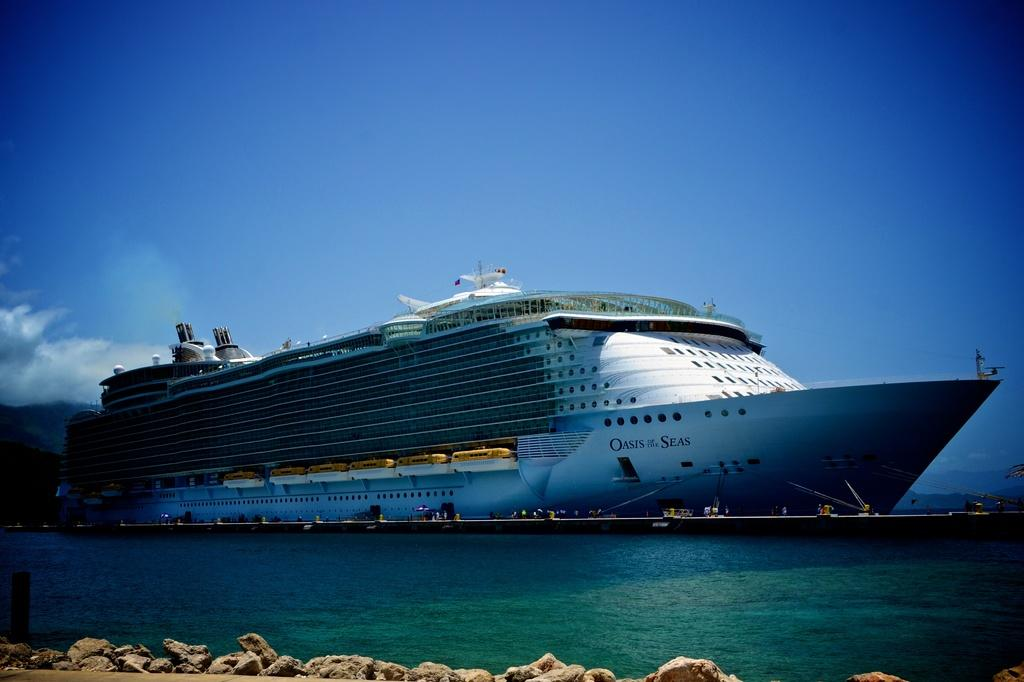What is the main subject of the image? The main subject of the image is a ship visible on the lake. What can be seen at the bottom of the image? There are stones at the bottom of the image. What is visible at the top of the image? The sky is visible at the top of the image. What type of lumber is being used to build the ship in the image? There is no indication of the ship's construction materials in the image, so it cannot be determined from the image alone. 